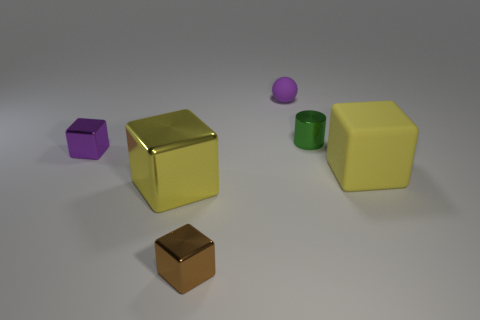Add 4 tiny yellow balls. How many objects exist? 10 Subtract all shiny blocks. How many blocks are left? 1 Subtract all brown cubes. How many cubes are left? 3 Subtract all blocks. How many objects are left? 2 Subtract 1 spheres. How many spheres are left? 0 Subtract all blue spheres. Subtract all purple blocks. How many spheres are left? 1 Subtract all red balls. How many purple blocks are left? 1 Subtract all small metal cylinders. Subtract all shiny objects. How many objects are left? 1 Add 5 tiny brown metallic cubes. How many tiny brown metallic cubes are left? 6 Add 3 large cyan cubes. How many large cyan cubes exist? 3 